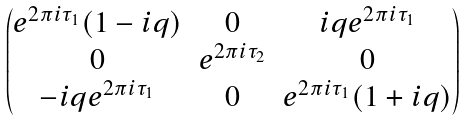<formula> <loc_0><loc_0><loc_500><loc_500>\begin{pmatrix} e ^ { 2 \pi i \tau _ { 1 } } ( 1 - i q ) & 0 & i q e ^ { 2 \pi i \tau _ { 1 } } \\ 0 & e ^ { 2 \pi i \tau _ { 2 } } & 0 \\ - i q e ^ { 2 \pi i \tau _ { 1 } } & 0 & e ^ { 2 \pi i \tau _ { 1 } } ( 1 + i q ) \end{pmatrix}</formula> 